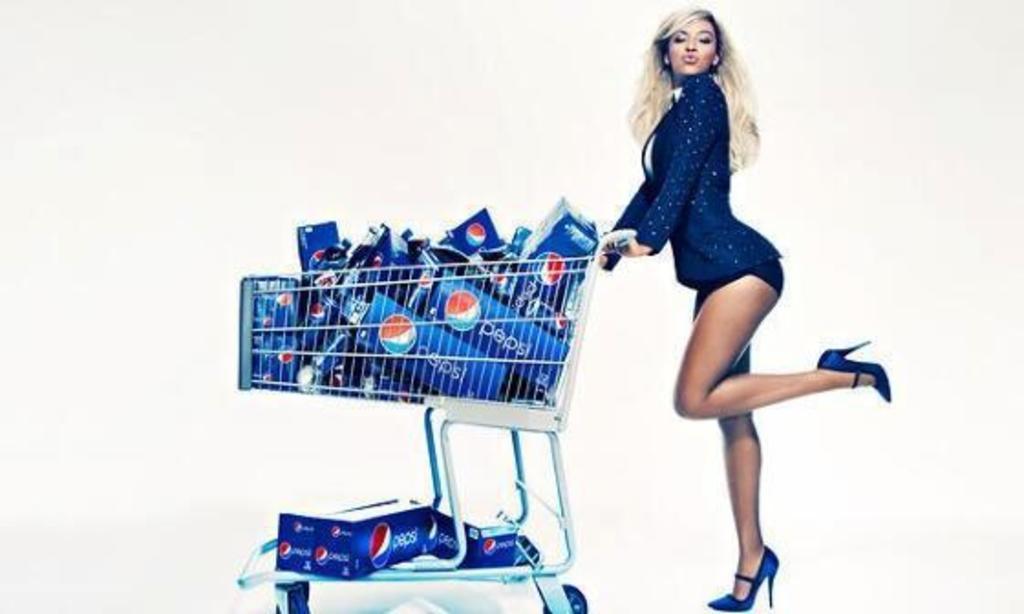Please provide a concise description of this image. In this image we can see a girl holding a cart. In the car we can see bottles. 